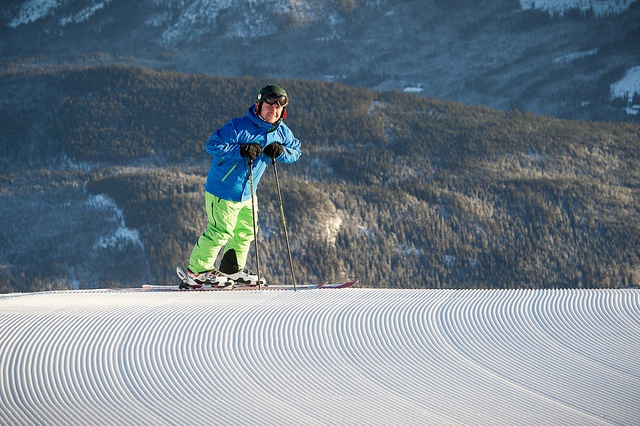Describe the objects in this image and their specific colors. I can see people in darkblue, blue, black, beige, and lightgreen tones, skis in darkblue, darkgray, gray, lightgray, and black tones, and baseball glove in darkblue, black, and gray tones in this image. 